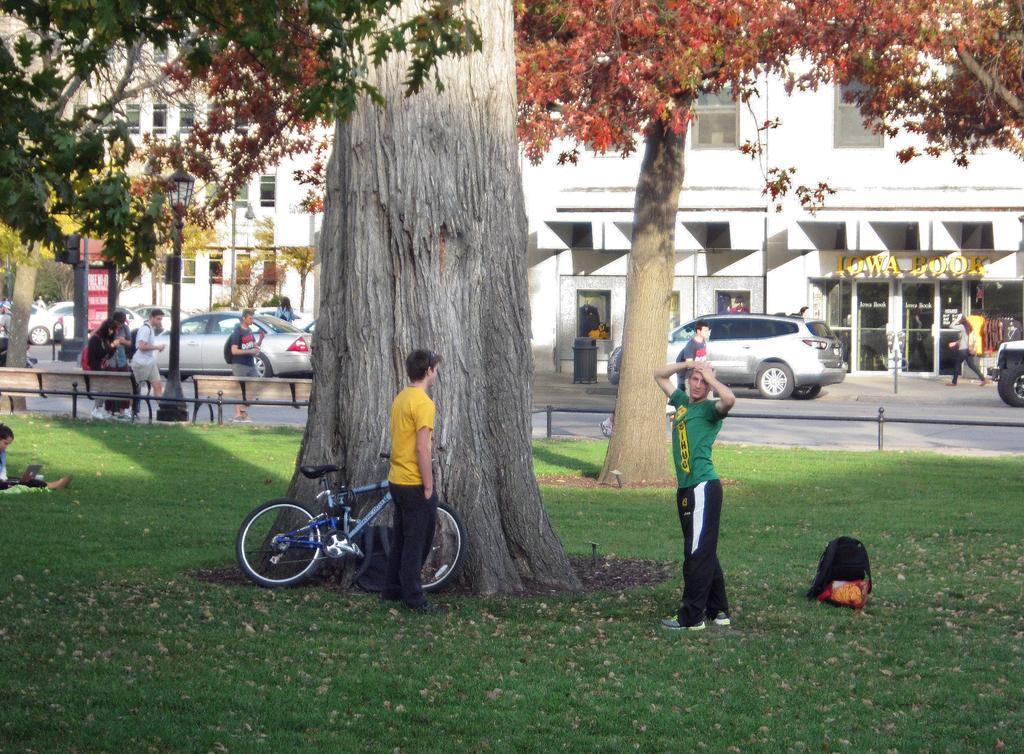Could you give a brief overview of what you see in this image? In this image I can see few people are on the ground. I can see the bicycle, bag and many trees on the ground. To the side I can see the benches. To the side of the branches I can see the road. On the road I can see many vehicles and the group of people with different color dresses. In the background I can see the buildings with windows and the boards. 